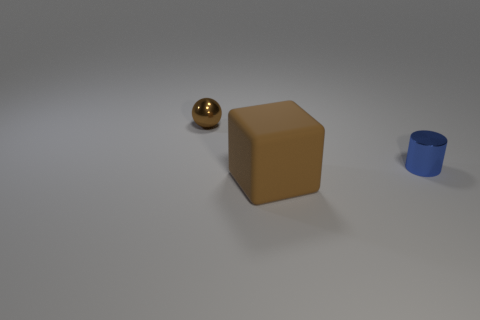Add 3 brown blocks. How many objects exist? 6 Subtract all balls. How many objects are left? 2 Subtract all tiny purple matte cylinders. Subtract all shiny objects. How many objects are left? 1 Add 1 big brown objects. How many big brown objects are left? 2 Add 1 large red shiny things. How many large red shiny things exist? 1 Subtract 0 cyan cylinders. How many objects are left? 3 